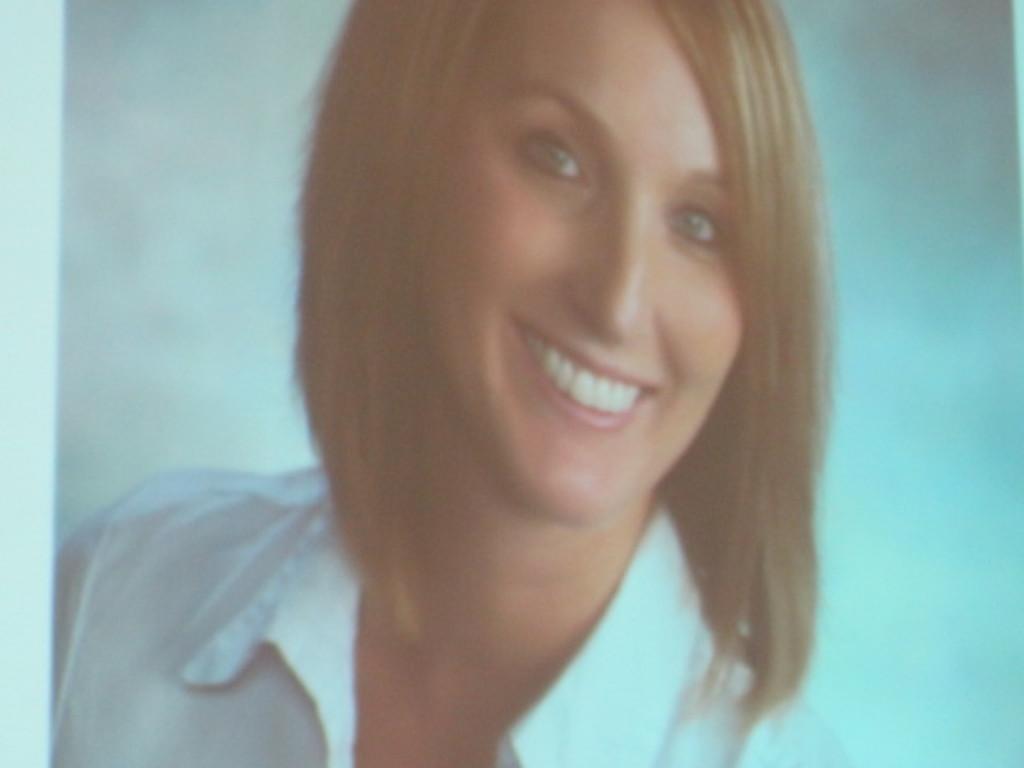Can you describe this image briefly? In this image we can see a woman wearing white shirt is smiling. The background of the image is in white color. 